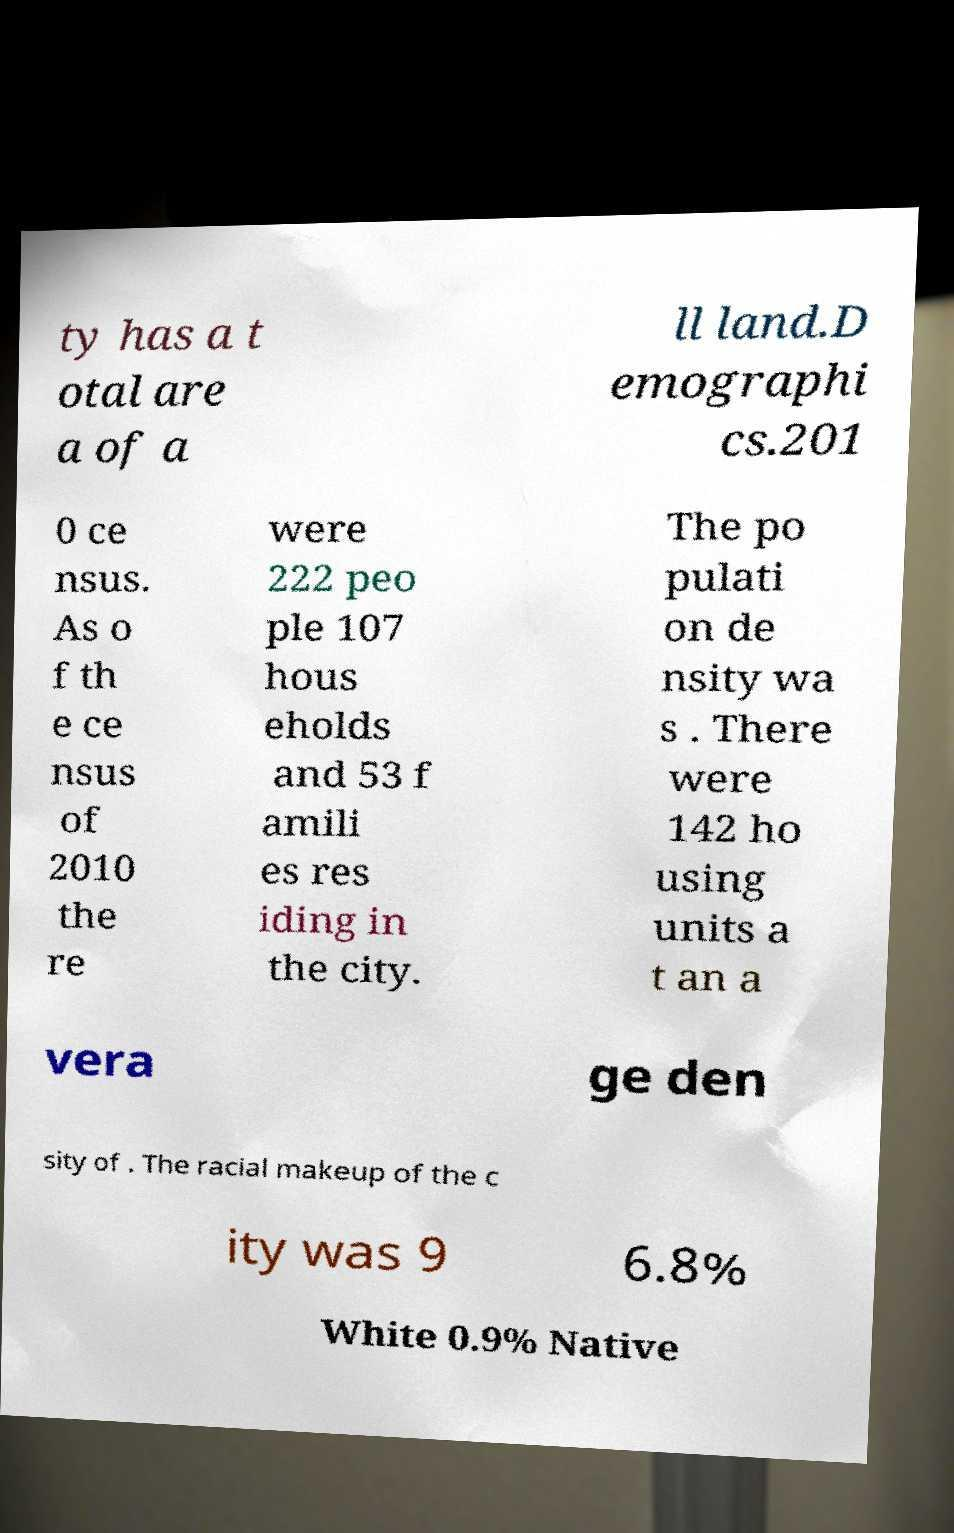Can you accurately transcribe the text from the provided image for me? ty has a t otal are a of a ll land.D emographi cs.201 0 ce nsus. As o f th e ce nsus of 2010 the re were 222 peo ple 107 hous eholds and 53 f amili es res iding in the city. The po pulati on de nsity wa s . There were 142 ho using units a t an a vera ge den sity of . The racial makeup of the c ity was 9 6.8% White 0.9% Native 